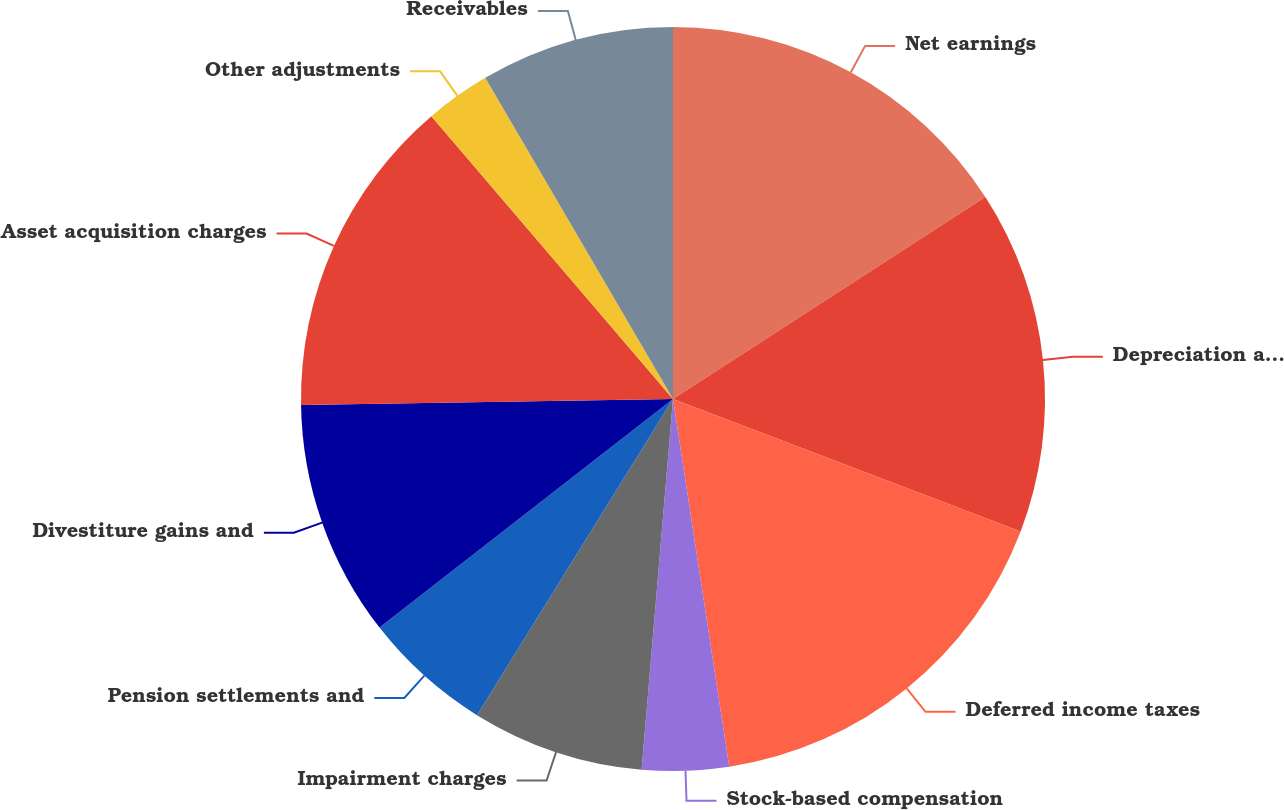<chart> <loc_0><loc_0><loc_500><loc_500><pie_chart><fcel>Net earnings<fcel>Depreciation and amortization<fcel>Deferred income taxes<fcel>Stock-based compensation<fcel>Impairment charges<fcel>Pension settlements and<fcel>Divestiture gains and<fcel>Asset acquisition charges<fcel>Other adjustments<fcel>Receivables<nl><fcel>15.86%<fcel>14.93%<fcel>16.79%<fcel>3.76%<fcel>7.49%<fcel>5.63%<fcel>10.28%<fcel>14.0%<fcel>2.83%<fcel>8.42%<nl></chart> 